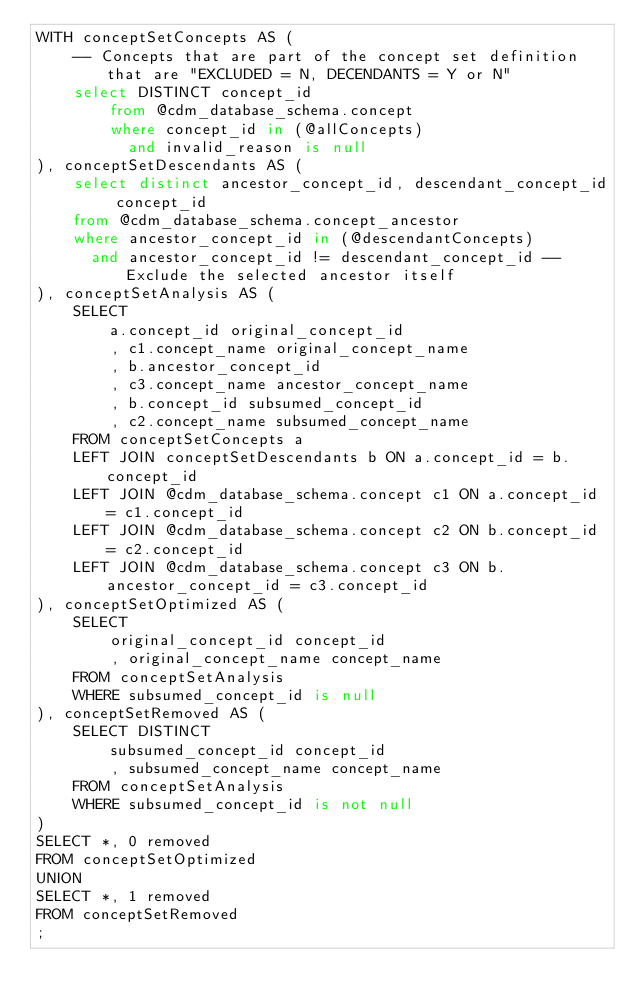<code> <loc_0><loc_0><loc_500><loc_500><_SQL_>WITH conceptSetConcepts AS (
	-- Concepts that are part of the concept set definition that are "EXCLUDED = N, DECENDANTS = Y or N"
	select DISTINCT concept_id 
        from @cdm_database_schema.concept
        where concept_id in (@allConcepts)
          and invalid_reason is null
), conceptSetDescendants AS (
	select distinct ancestor_concept_id, descendant_concept_id concept_id
	from @cdm_database_schema.concept_ancestor
	where ancestor_concept_id in (@descendantConcepts)
	  and ancestor_concept_id != descendant_concept_id -- Exclude the selected ancestor itself
), conceptSetAnalysis AS (
	SELECT 
		a.concept_id original_concept_id
		, c1.concept_name original_concept_name
		, b.ancestor_concept_id
		, c3.concept_name ancestor_concept_name
		, b.concept_id subsumed_concept_id
		, c2.concept_name subsumed_concept_name
	FROM conceptSetConcepts a
	LEFT JOIN conceptSetDescendants b ON a.concept_id = b.concept_id
	LEFT JOIN @cdm_database_schema.concept c1 ON a.concept_id = c1.concept_id
	LEFT JOIN @cdm_database_schema.concept c2 ON b.concept_id = c2.concept_id
	LEFT JOIN @cdm_database_schema.concept c3 ON b.ancestor_concept_id = c3.concept_id
), conceptSetOptimized AS (
	SELECT 
		original_concept_id concept_id
		, original_concept_name concept_name
	FROM conceptSetAnalysis
	WHERE subsumed_concept_id is null
), conceptSetRemoved AS (
	SELECT DISTINCT 
		subsumed_concept_id concept_id
		, subsumed_concept_name concept_name
	FROM conceptSetAnalysis
	WHERE subsumed_concept_id is not null
)	
SELECT *, 0 removed
FROM conceptSetOptimized
UNION
SELECT *, 1 removed
FROM conceptSetRemoved
;</code> 